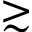Convert formula to latex. <formula><loc_0><loc_0><loc_500><loc_500>\gtrsim</formula> 